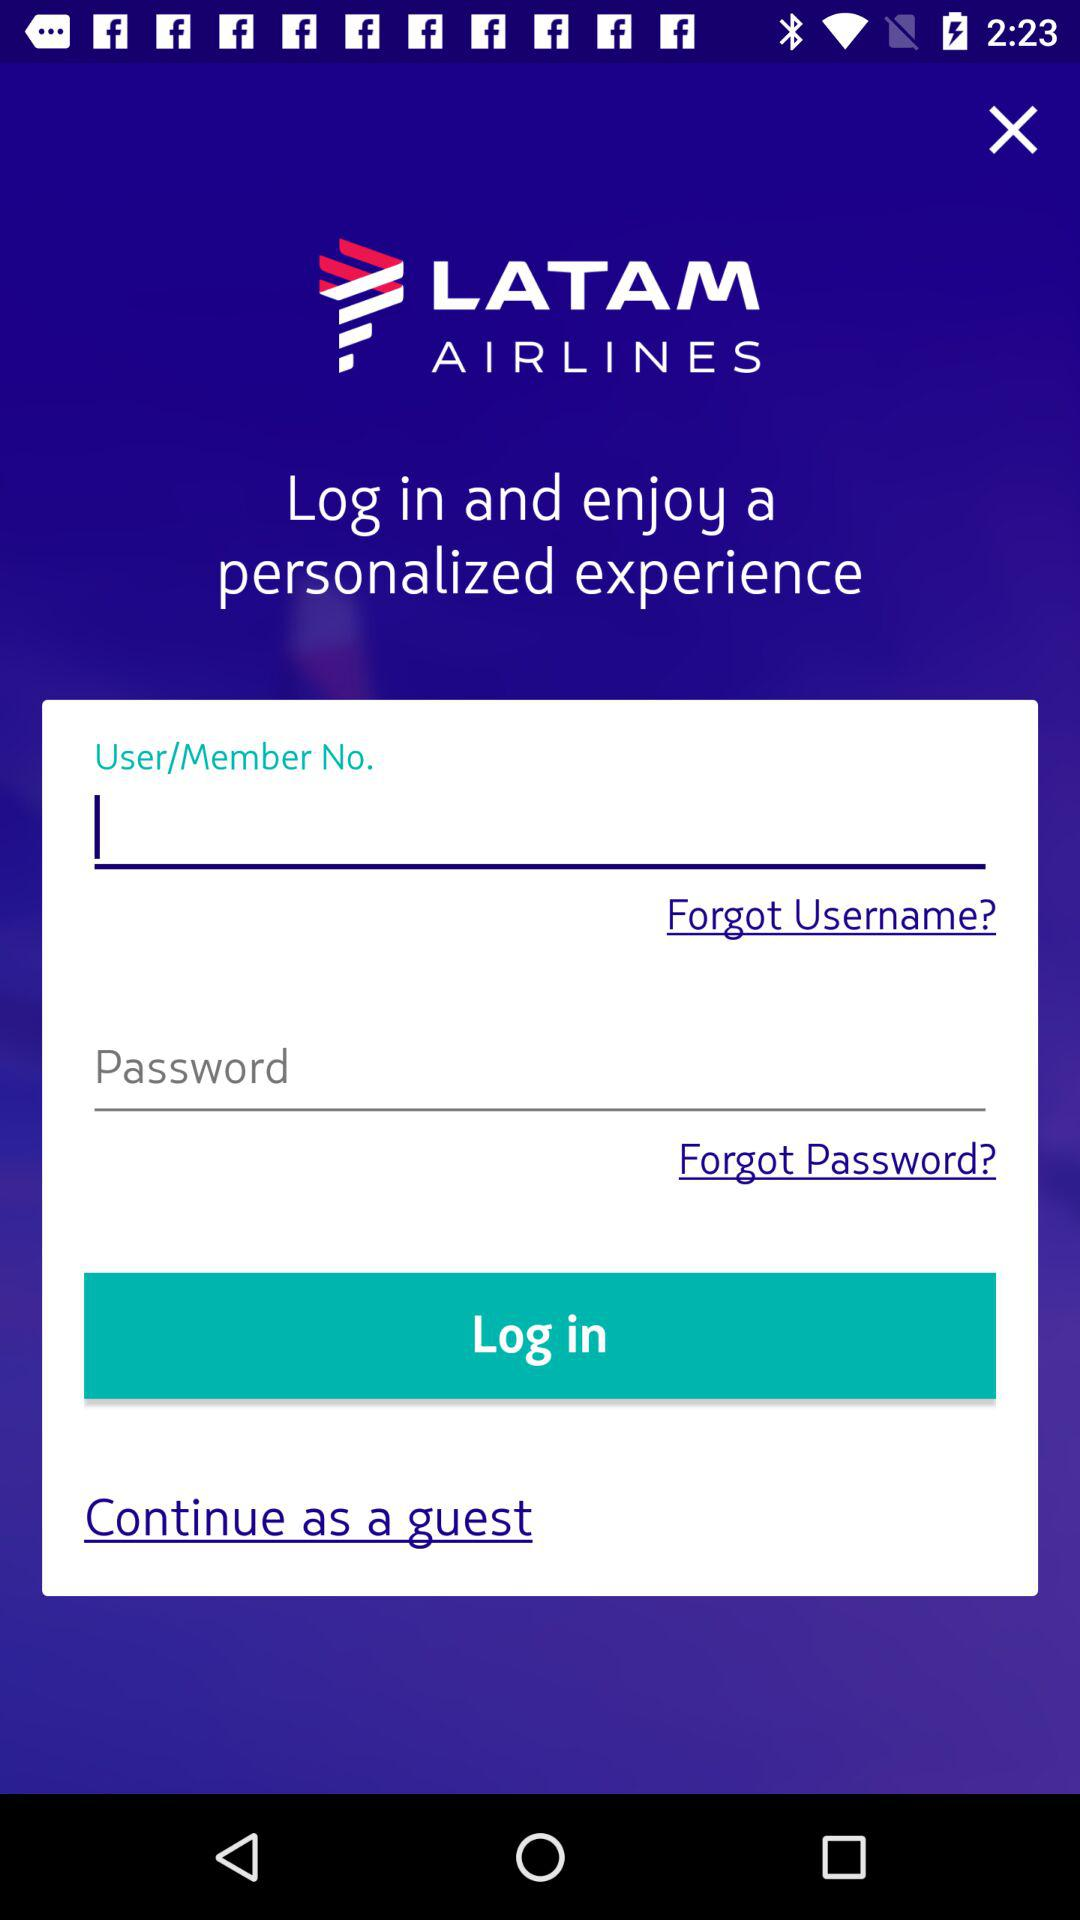Can we reset password?
When the provided information is insufficient, respond with <no answer>. <no answer> 